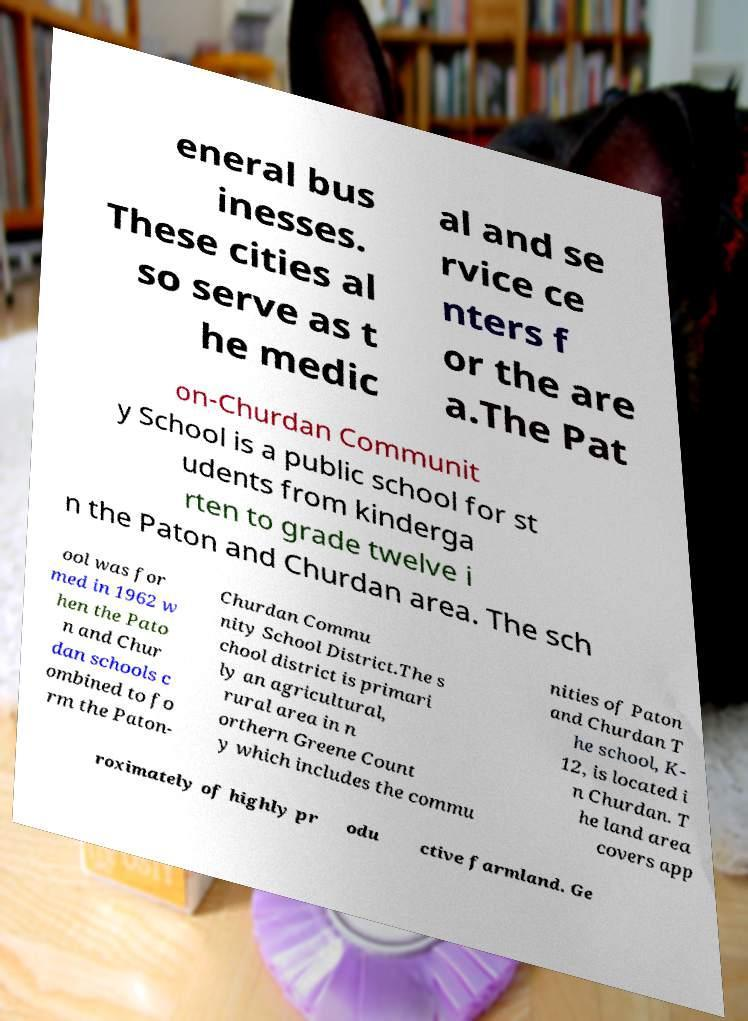Can you accurately transcribe the text from the provided image for me? eneral bus inesses. These cities al so serve as t he medic al and se rvice ce nters f or the are a.The Pat on-Churdan Communit y School is a public school for st udents from kinderga rten to grade twelve i n the Paton and Churdan area. The sch ool was for med in 1962 w hen the Pato n and Chur dan schools c ombined to fo rm the Paton- Churdan Commu nity School District.The s chool district is primari ly an agricultural, rural area in n orthern Greene Count y which includes the commu nities of Paton and Churdan T he school, K- 12, is located i n Churdan. T he land area covers app roximately of highly pr odu ctive farmland. Ge 